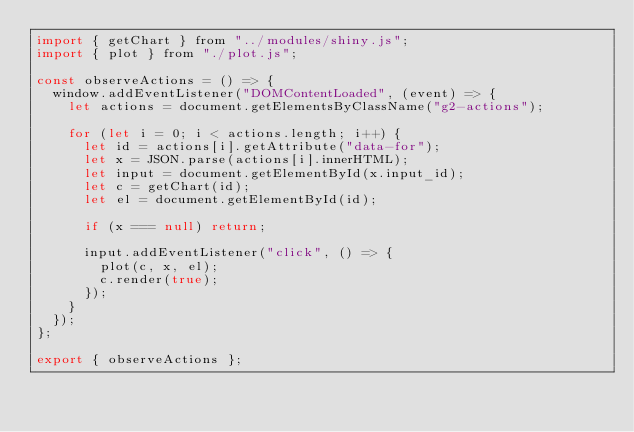<code> <loc_0><loc_0><loc_500><loc_500><_JavaScript_>import { getChart } from "../modules/shiny.js";
import { plot } from "./plot.js";

const observeActions = () => {
  window.addEventListener("DOMContentLoaded", (event) => {
    let actions = document.getElementsByClassName("g2-actions");

    for (let i = 0; i < actions.length; i++) {
      let id = actions[i].getAttribute("data-for");
      let x = JSON.parse(actions[i].innerHTML);
      let input = document.getElementById(x.input_id);
      let c = getChart(id);
      let el = document.getElementById(id);

      if (x === null) return;

      input.addEventListener("click", () => {
        plot(c, x, el);
        c.render(true);
      });
    }
  });
};

export { observeActions };
</code> 